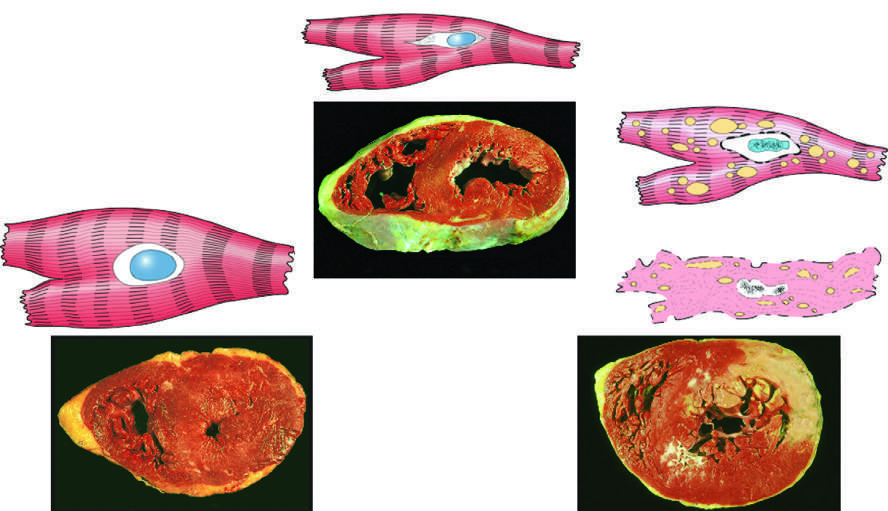does an infarct in the brain show functional effects without any gross or light microscopic changes, or reversible changes such as cellular swelling and fatty change (shown here)?
Answer the question using a single word or phrase. No 